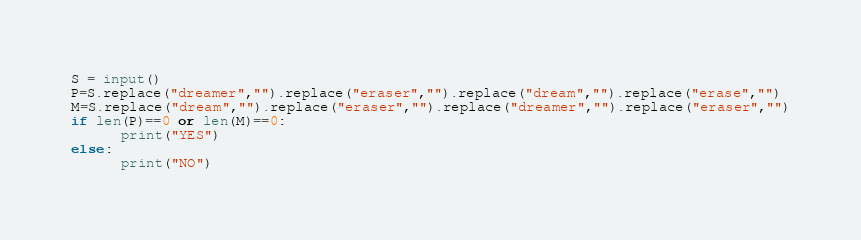<code> <loc_0><loc_0><loc_500><loc_500><_Python_>S = input()
P=S.replace("dreamer","").replace("eraser","").replace("dream","").replace("erase","")
M=S.replace("dream","").replace("eraser","").replace("dreamer","").replace("eraser","")
if len(P)==0 or len(M)==0:
      print("YES")
else:
      print("NO")</code> 